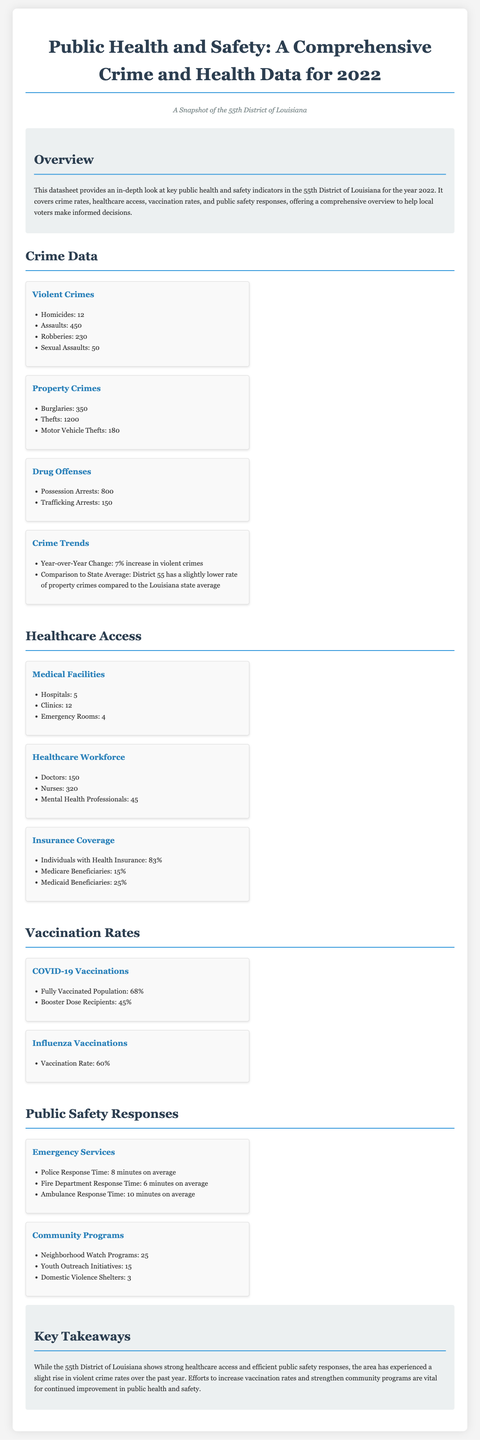What was the total number of homicides in 2022? The total number of homicides is listed in the Violent Crimes section, which states there were 12 homicides.
Answer: 12 What percentage of individuals has health insurance in the district? The percentage of individuals with health insurance is provided in the Insurance Coverage section, which states 83%.
Answer: 83% How many emergency rooms are there in the 55th District? The number of emergency rooms is specified in the Medical Facilities section, which lists 4 emergency rooms.
Answer: 4 What is the average police response time? The average police response time is stated in the Emergency Services section, listed as 8 minutes on average.
Answer: 8 minutes What was the year-over-year change in violent crimes? The year-over-year change in violent crimes is included in the Crime Trends section, which indicates a 7% increase.
Answer: 7% increase How many burglaries were reported in 2022? The number of burglaries is detailed in the Property Crimes section, indicating 350 burglaries.
Answer: 350 What proportion of the population is fully vaccinated against COVID-19? The proportion of the population that is fully vaccinated is found in the COVID-19 Vaccinations section, which states 68%.
Answer: 68% How many neighborhood watch programs are active in the district? The number of neighborhood watch programs is mentioned in the Community Programs section, which states there are 25 programs.
Answer: 25 What are the total medical facilities available, including hospitals and clinics? The total medical facilities include 5 hospitals and 12 clinics, making it 17 in total.
Answer: 17 